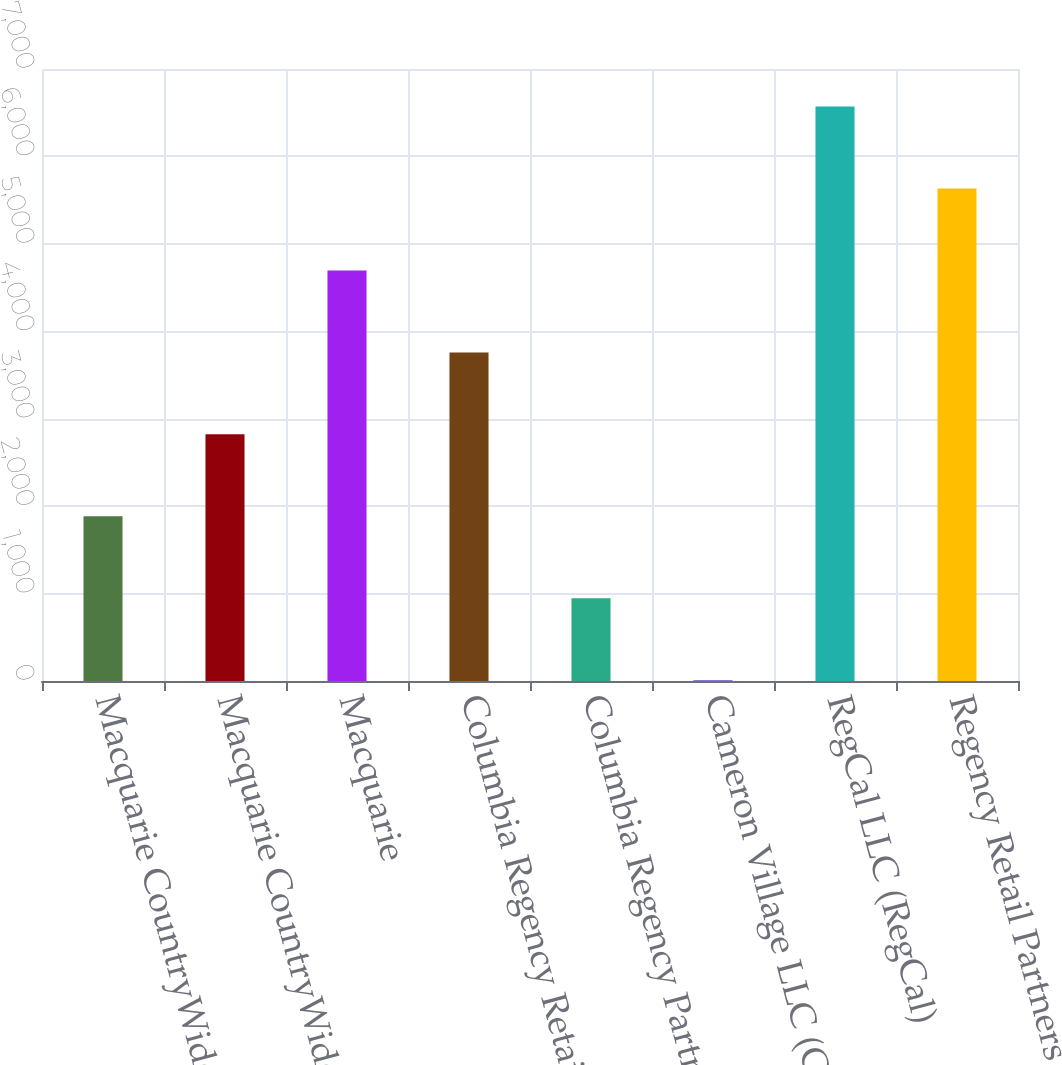Convert chart to OTSL. <chart><loc_0><loc_0><loc_500><loc_500><bar_chart><fcel>Macquarie CountryWide-Regency<fcel>Macquarie CountryWide Direct<fcel>Macquarie<fcel>Columbia Regency Retail<fcel>Columbia Regency Partners II<fcel>Cameron Village LLC (Cameron)<fcel>RegCal LLC (RegCal)<fcel>Regency Retail Partners (the<nl><fcel>1883.8<fcel>2821.2<fcel>4696<fcel>3758.6<fcel>946.4<fcel>9<fcel>6570.8<fcel>5633.4<nl></chart> 